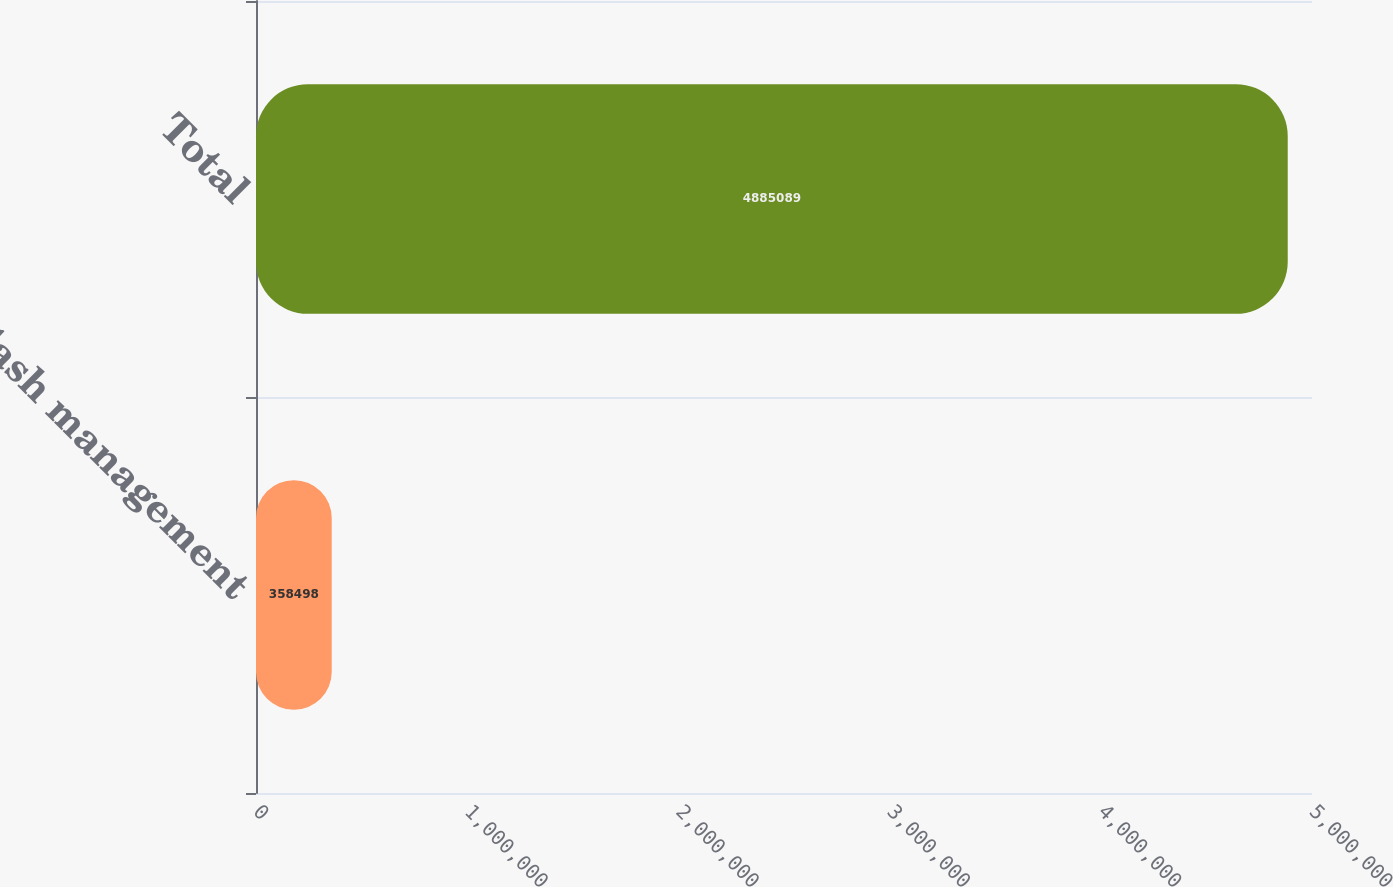Convert chart. <chart><loc_0><loc_0><loc_500><loc_500><bar_chart><fcel>Cash management<fcel>Total<nl><fcel>358498<fcel>4.88509e+06<nl></chart> 